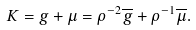Convert formula to latex. <formula><loc_0><loc_0><loc_500><loc_500>K = g + \mu = \rho ^ { - 2 } \overline { g } + \rho ^ { - 1 } \overline { \mu } .</formula> 